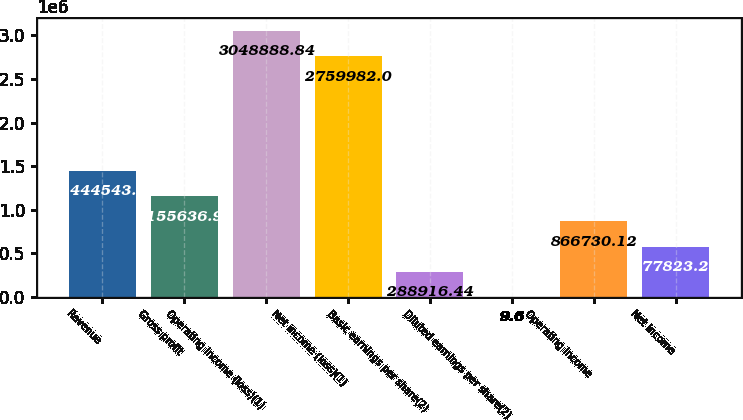Convert chart. <chart><loc_0><loc_0><loc_500><loc_500><bar_chart><fcel>Revenue<fcel>Gross profit<fcel>Operating income (loss)(1)<fcel>Net income (loss)(1)<fcel>Basic earnings per share(2)<fcel>Diluted earnings per share(2)<fcel>Operating income<fcel>Net income<nl><fcel>1.44454e+06<fcel>1.15564e+06<fcel>3.04889e+06<fcel>2.75998e+06<fcel>288916<fcel>9.6<fcel>866730<fcel>577823<nl></chart> 